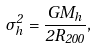Convert formula to latex. <formula><loc_0><loc_0><loc_500><loc_500>\sigma _ { h } ^ { 2 } = \frac { G M _ { h } } { 2 R _ { 2 0 0 } } ,</formula> 